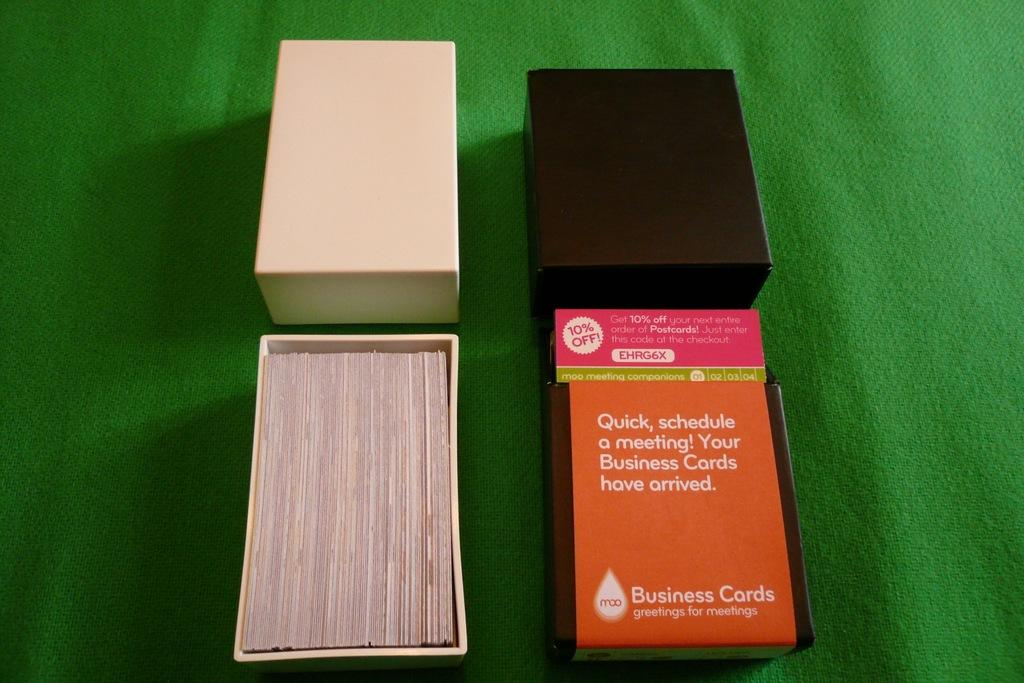<image>
Describe the image concisely. Business card boxes are shown on a green setting designed at moo 